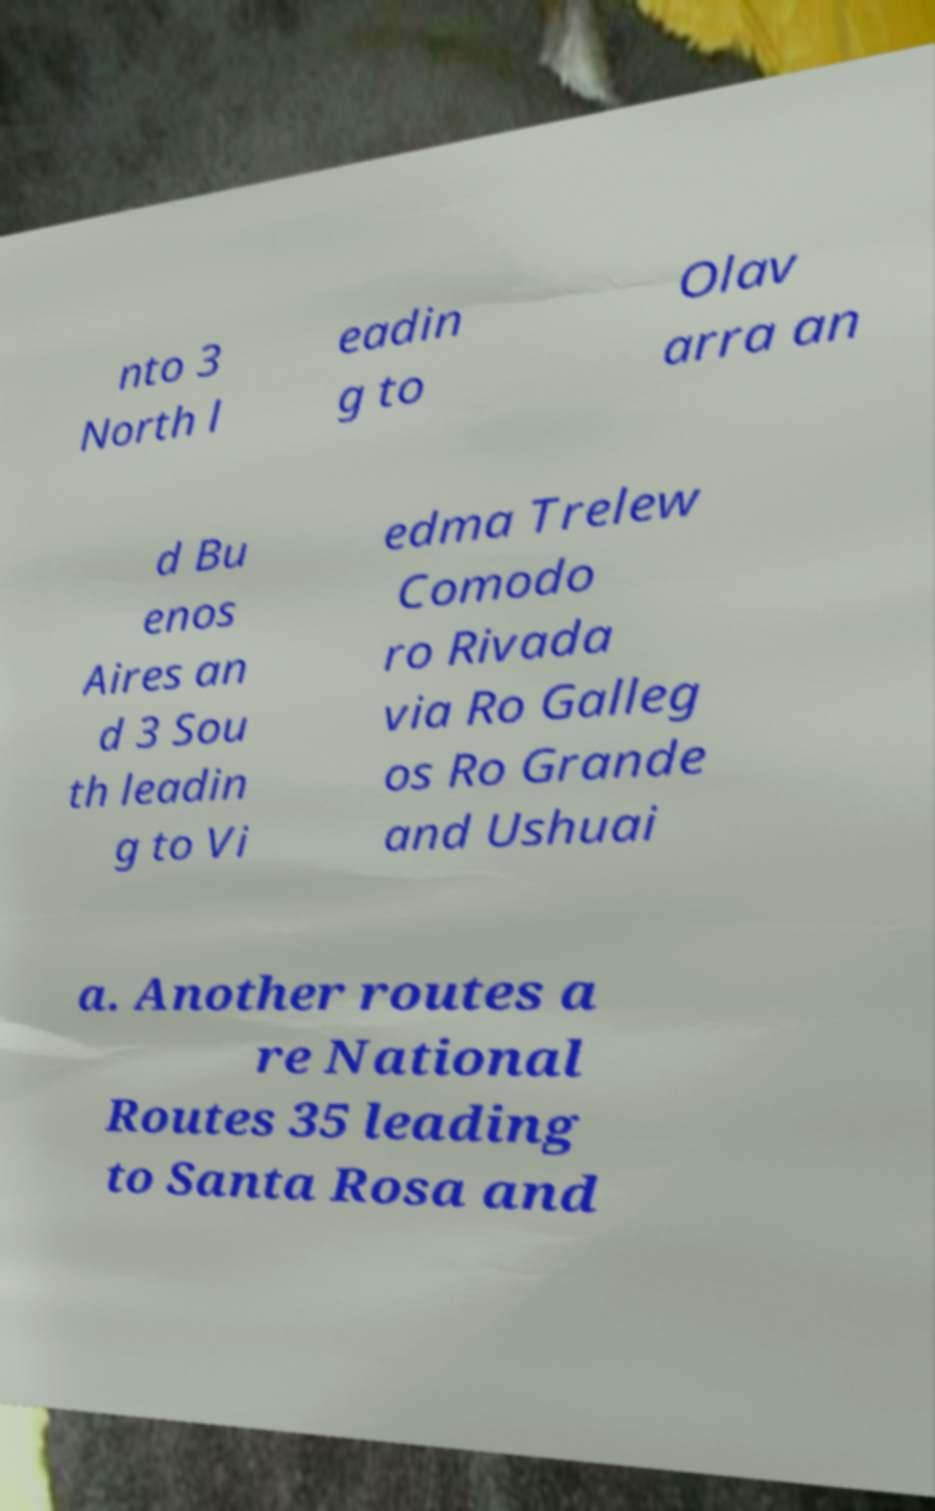Can you accurately transcribe the text from the provided image for me? nto 3 North l eadin g to Olav arra an d Bu enos Aires an d 3 Sou th leadin g to Vi edma Trelew Comodo ro Rivada via Ro Galleg os Ro Grande and Ushuai a. Another routes a re National Routes 35 leading to Santa Rosa and 